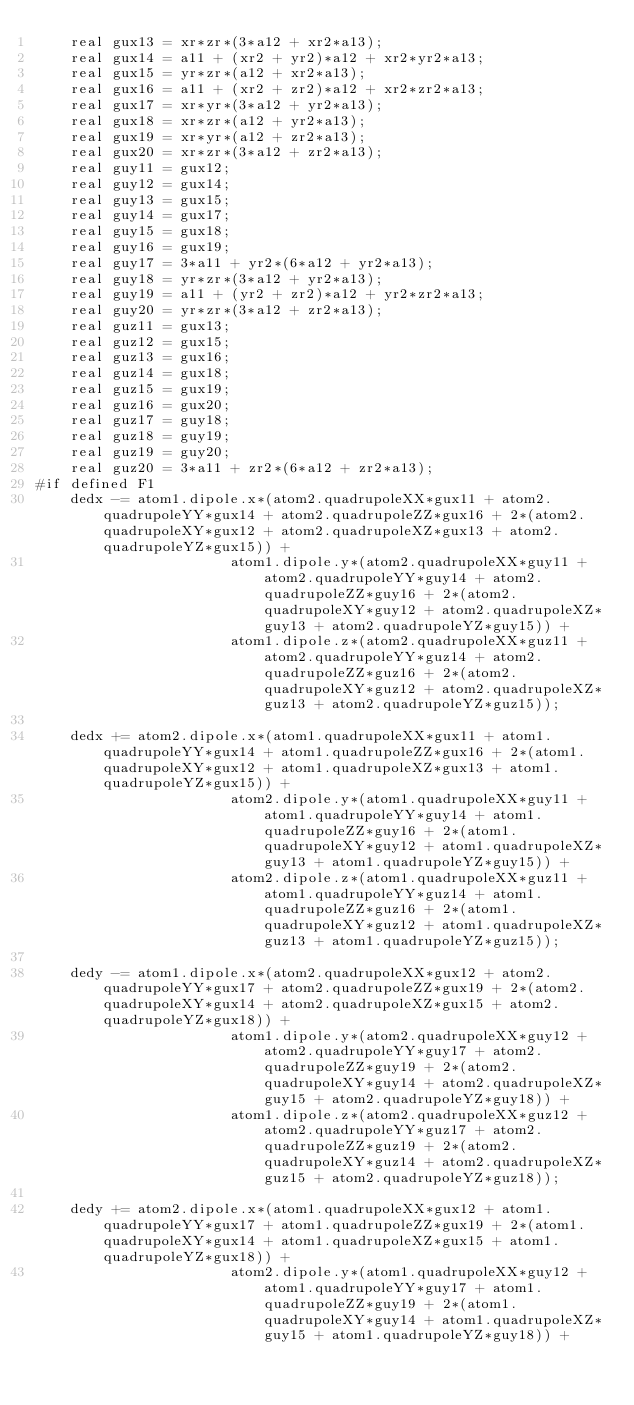Convert code to text. <code><loc_0><loc_0><loc_500><loc_500><_Cuda_>    real gux13 = xr*zr*(3*a12 + xr2*a13);
    real gux14 = a11 + (xr2 + yr2)*a12 + xr2*yr2*a13;
    real gux15 = yr*zr*(a12 + xr2*a13);
    real gux16 = a11 + (xr2 + zr2)*a12 + xr2*zr2*a13;
    real gux17 = xr*yr*(3*a12 + yr2*a13);
    real gux18 = xr*zr*(a12 + yr2*a13);
    real gux19 = xr*yr*(a12 + zr2*a13);
    real gux20 = xr*zr*(3*a12 + zr2*a13);
    real guy11 = gux12;
    real guy12 = gux14;
    real guy13 = gux15;
    real guy14 = gux17;
    real guy15 = gux18;
    real guy16 = gux19;
    real guy17 = 3*a11 + yr2*(6*a12 + yr2*a13);
    real guy18 = yr*zr*(3*a12 + yr2*a13);
    real guy19 = a11 + (yr2 + zr2)*a12 + yr2*zr2*a13;
    real guy20 = yr*zr*(3*a12 + zr2*a13);
    real guz11 = gux13;
    real guz12 = gux15;
    real guz13 = gux16;
    real guz14 = gux18;
    real guz15 = gux19;
    real guz16 = gux20;
    real guz17 = guy18;
    real guz18 = guy19;
    real guz19 = guy20;
    real guz20 = 3*a11 + zr2*(6*a12 + zr2*a13);
#if defined F1
    dedx -= atom1.dipole.x*(atom2.quadrupoleXX*gux11 + atom2.quadrupoleYY*gux14 + atom2.quadrupoleZZ*gux16 + 2*(atom2.quadrupoleXY*gux12 + atom2.quadrupoleXZ*gux13 + atom2.quadrupoleYZ*gux15)) +
                       atom1.dipole.y*(atom2.quadrupoleXX*guy11 + atom2.quadrupoleYY*guy14 + atom2.quadrupoleZZ*guy16 + 2*(atom2.quadrupoleXY*guy12 + atom2.quadrupoleXZ*guy13 + atom2.quadrupoleYZ*guy15)) +
                       atom1.dipole.z*(atom2.quadrupoleXX*guz11 + atom2.quadrupoleYY*guz14 + atom2.quadrupoleZZ*guz16 + 2*(atom2.quadrupoleXY*guz12 + atom2.quadrupoleXZ*guz13 + atom2.quadrupoleYZ*guz15));

    dedx += atom2.dipole.x*(atom1.quadrupoleXX*gux11 + atom1.quadrupoleYY*gux14 + atom1.quadrupoleZZ*gux16 + 2*(atom1.quadrupoleXY*gux12 + atom1.quadrupoleXZ*gux13 + atom1.quadrupoleYZ*gux15)) +
                       atom2.dipole.y*(atom1.quadrupoleXX*guy11 + atom1.quadrupoleYY*guy14 + atom1.quadrupoleZZ*guy16 + 2*(atom1.quadrupoleXY*guy12 + atom1.quadrupoleXZ*guy13 + atom1.quadrupoleYZ*guy15)) +
                       atom2.dipole.z*(atom1.quadrupoleXX*guz11 + atom1.quadrupoleYY*guz14 + atom1.quadrupoleZZ*guz16 + 2*(atom1.quadrupoleXY*guz12 + atom1.quadrupoleXZ*guz13 + atom1.quadrupoleYZ*guz15));

    dedy -= atom1.dipole.x*(atom2.quadrupoleXX*gux12 + atom2.quadrupoleYY*gux17 + atom2.quadrupoleZZ*gux19 + 2*(atom2.quadrupoleXY*gux14 + atom2.quadrupoleXZ*gux15 + atom2.quadrupoleYZ*gux18)) +
                       atom1.dipole.y*(atom2.quadrupoleXX*guy12 + atom2.quadrupoleYY*guy17 + atom2.quadrupoleZZ*guy19 + 2*(atom2.quadrupoleXY*guy14 + atom2.quadrupoleXZ*guy15 + atom2.quadrupoleYZ*guy18)) +
                       atom1.dipole.z*(atom2.quadrupoleXX*guz12 + atom2.quadrupoleYY*guz17 + atom2.quadrupoleZZ*guz19 + 2*(atom2.quadrupoleXY*guz14 + atom2.quadrupoleXZ*guz15 + atom2.quadrupoleYZ*guz18));

    dedy += atom2.dipole.x*(atom1.quadrupoleXX*gux12 + atom1.quadrupoleYY*gux17 + atom1.quadrupoleZZ*gux19 + 2*(atom1.quadrupoleXY*gux14 + atom1.quadrupoleXZ*gux15 + atom1.quadrupoleYZ*gux18)) +
                       atom2.dipole.y*(atom1.quadrupoleXX*guy12 + atom1.quadrupoleYY*guy17 + atom1.quadrupoleZZ*guy19 + 2*(atom1.quadrupoleXY*guy14 + atom1.quadrupoleXZ*guy15 + atom1.quadrupoleYZ*guy18)) +</code> 